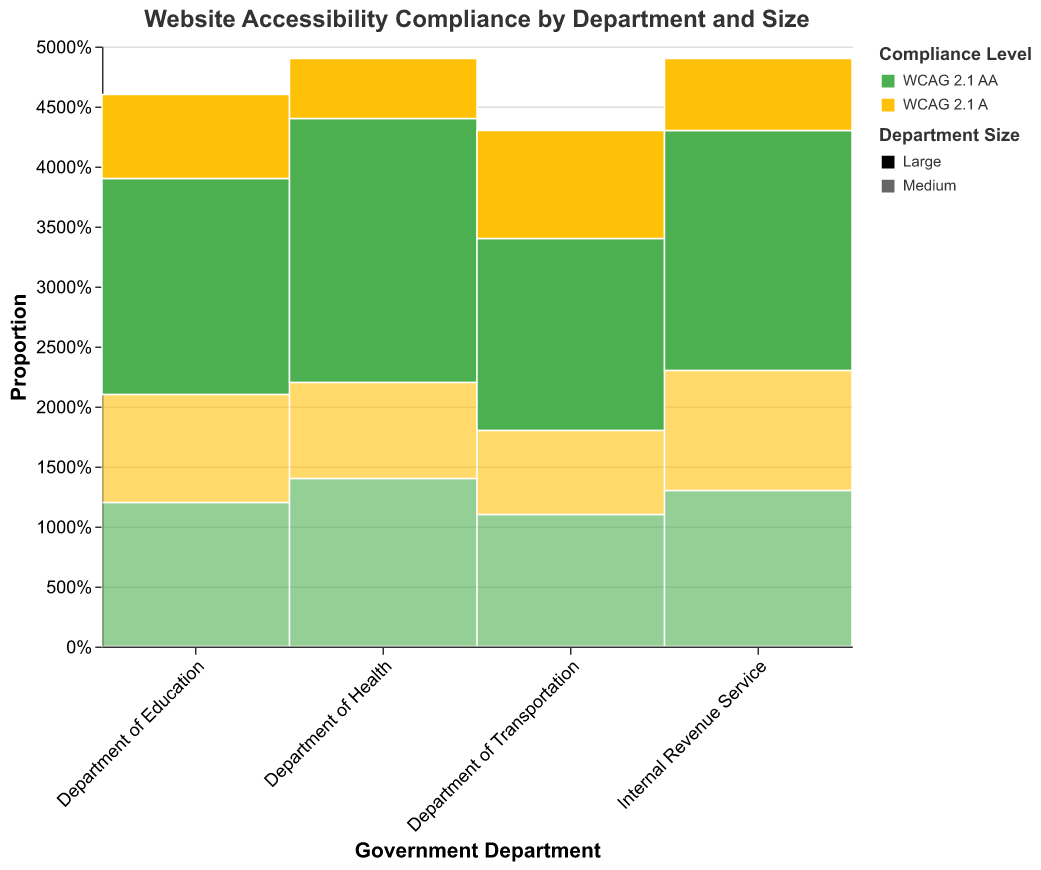What is the title of the plot? The title of the plot is located at the top and is displayed in larger font size.
Answer: Website Accessibility Compliance by Department and Size Which department has the highest number of large size websites complying with WCAG 2.1 AA standards? From the plot, observe the heights of the boxes representing "Large" websites with WCAG 2.1 AA compliance under each department. "Department of Health" has the tallest box in this category.
Answer: Department of Health In the Department of Education, which size has a higher compliance with WCAG 2.1 AA? Compare the heights of the boxes representing "Large" and "Medium" sizes within the Department of Education for WCAG 2.1 AA compliance. The box for "Large" is higher than that for "Medium".
Answer: Large What proportion of the Department of Transportation's websites have WCAG 2.1 A compliance for both size categories combined? Find the boxes labeled "Department of Transportation" with WCAG 2.1 A compliance and sum the heights (proportions) of "Large" and "Medium".
Answer: 16/43 Which department has the smallest difference in compliance level between WCAG 2.1 AA and WCAG 2.1 A for large websites? Compare the differences in heights between the WCAG 2.1 AA and WCAG 2.1 A compliance levels for large websites across all departments. "Department of Health" shows the smallest difference.
Answer: Department of Health How does the proportion of WCAG 2.1 A compliant large websites compare between the Department of Education and the Internal Revenue Service? Compare the heights of the boxes representing large WCAG 2.1 A compliant websites for the Department of Education and the Internal Revenue Service. The height for the Department of Education is higher than that for the Internal Revenue Service.
Answer: Department of Education > Internal Revenue Service What is the combined compliance rate of WCAG 2.1 AA across all websites in the Department of Health? Add the proportions (heights) of the boxes labeled "WCAG 2.1 AA" for both large and medium sizes in the Department of Health.
Answer: 36/49 